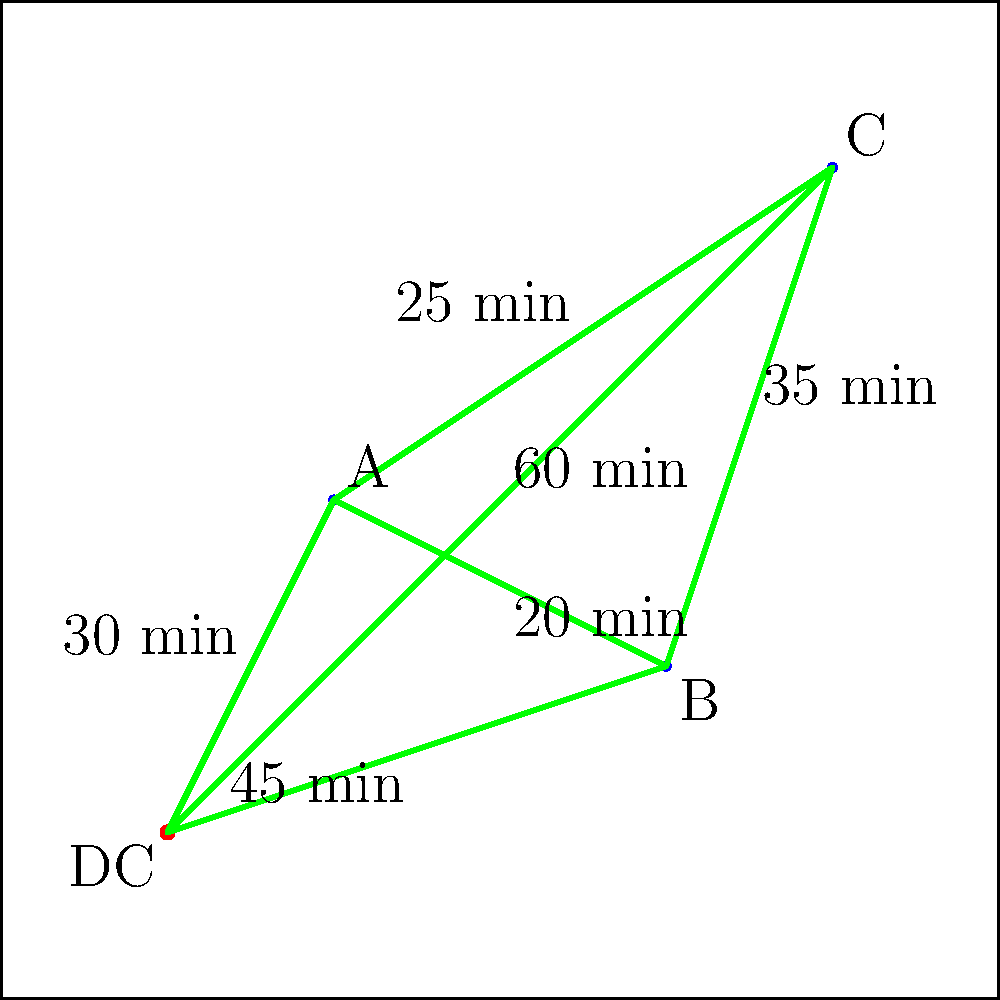As the founder of a health food company, you need to optimize the delivery routes for your products in a city. The map shows your distribution center (DC) and three delivery points (A, B, and C). The travel times between locations are indicated on the routes. What is the minimum time required to visit all three delivery points and return to the distribution center? To find the minimum time, we need to consider all possible routes and calculate their total time:

1. DC → A → B → C → DC
   Time: 30 + 20 + 35 + 60 = 145 minutes

2. DC → A → C → B → DC
   Time: 30 + 25 + 35 + 45 = 135 minutes

3. DC → B → A → C → DC
   Time: 45 + 20 + 25 + 60 = 150 minutes

4. DC → B → C → A → DC
   Time: 45 + 35 + 25 + 30 = 135 minutes

5. DC → C → A → B → DC
   Time: 60 + 25 + 20 + 45 = 150 minutes

6. DC → C → B → A → DC
   Time: 60 + 35 + 20 + 30 = 145 minutes

The minimum time is achieved by two routes:
- DC → A → C → B → DC
- DC → B → C → A → DC

Both routes take 135 minutes.
Answer: 135 minutes 